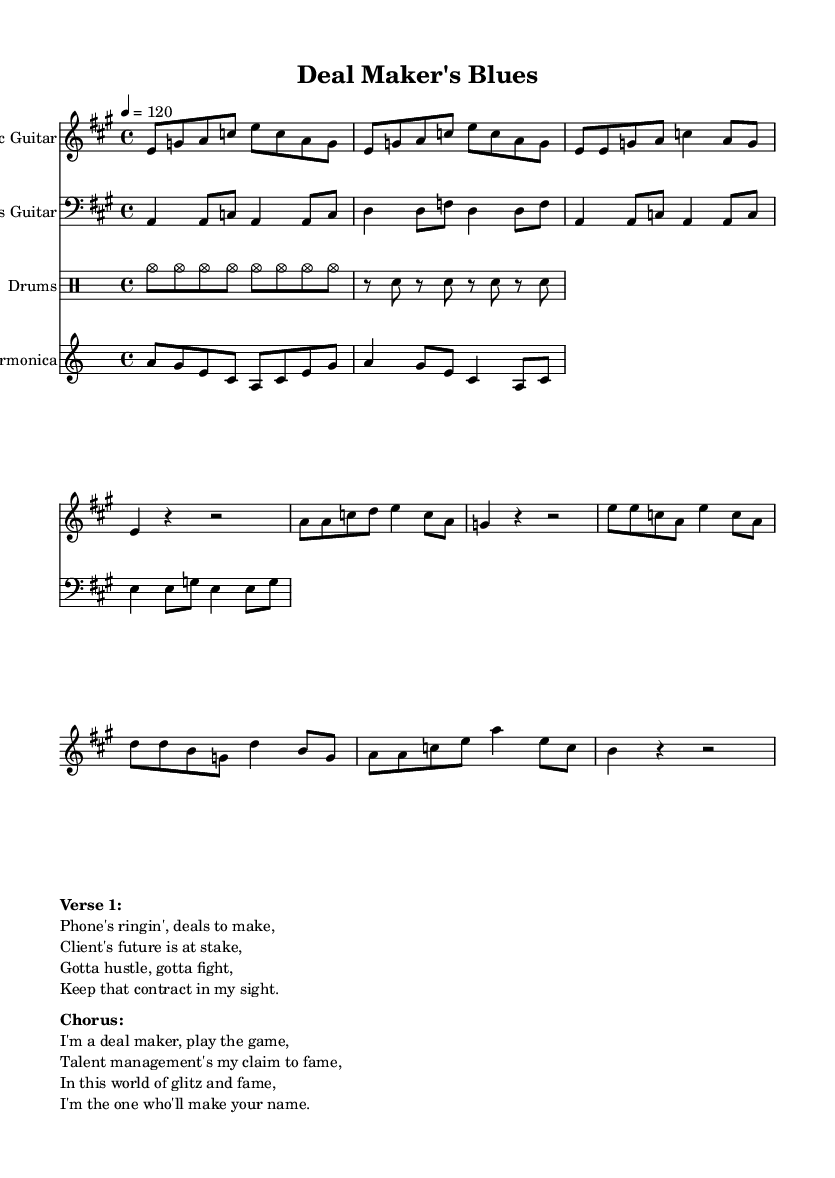What is the key signature of this music? The key signature is A major, which has three sharps: F#, C#, and G#. It can be identified in the key signature area at the beginning of the staff.
Answer: A major What is the time signature of this piece? The time signature shown is 4/4, indicating there are four beats in a measure and the quarter note receives one beat. This can be found at the beginning of the music score where time signatures are typically indicated.
Answer: 4/4 What is the tempo marking of the piece? The tempo marking is quarter note equals 120, which indicates that each quarter note should be played at a speed of 120 beats per minute. This is stated in the tempo indication near the beginning of the score.
Answer: 120 What instrument plays the melody in this piece? The melody is primarily played by the Electric Guitar, which is indicated as the first staff in the score. This is further supported by noting that the Electric Guitar line contains the main notes of the melody.
Answer: Electric Guitar How many different instruments are featured in this music? There are four different instruments featured: Electric Guitar, Bass Guitar, Drums, and Harmonica. This can be determined by counting the distinct staffs in the score, each labeled with the corresponding instrument name.
Answer: Four What type of rhythmic pattern is used in the drum part? The drum part uses a steady eighth-note pattern followed by a snare hit alternating with rests, which creates a typical rhythmic feel for electric blues music. This can be observed in the drum notation section where the rhythm is laid out.
Answer: Steady eighth-note What theme do the lyrics in the verse predominantly express? The lyrics express themes of ambition and the pursuit of client representation in the competitive music industry. This can be inferred by analyzing the content of the text presented under the verse section in the score.
Answer: Ambition 